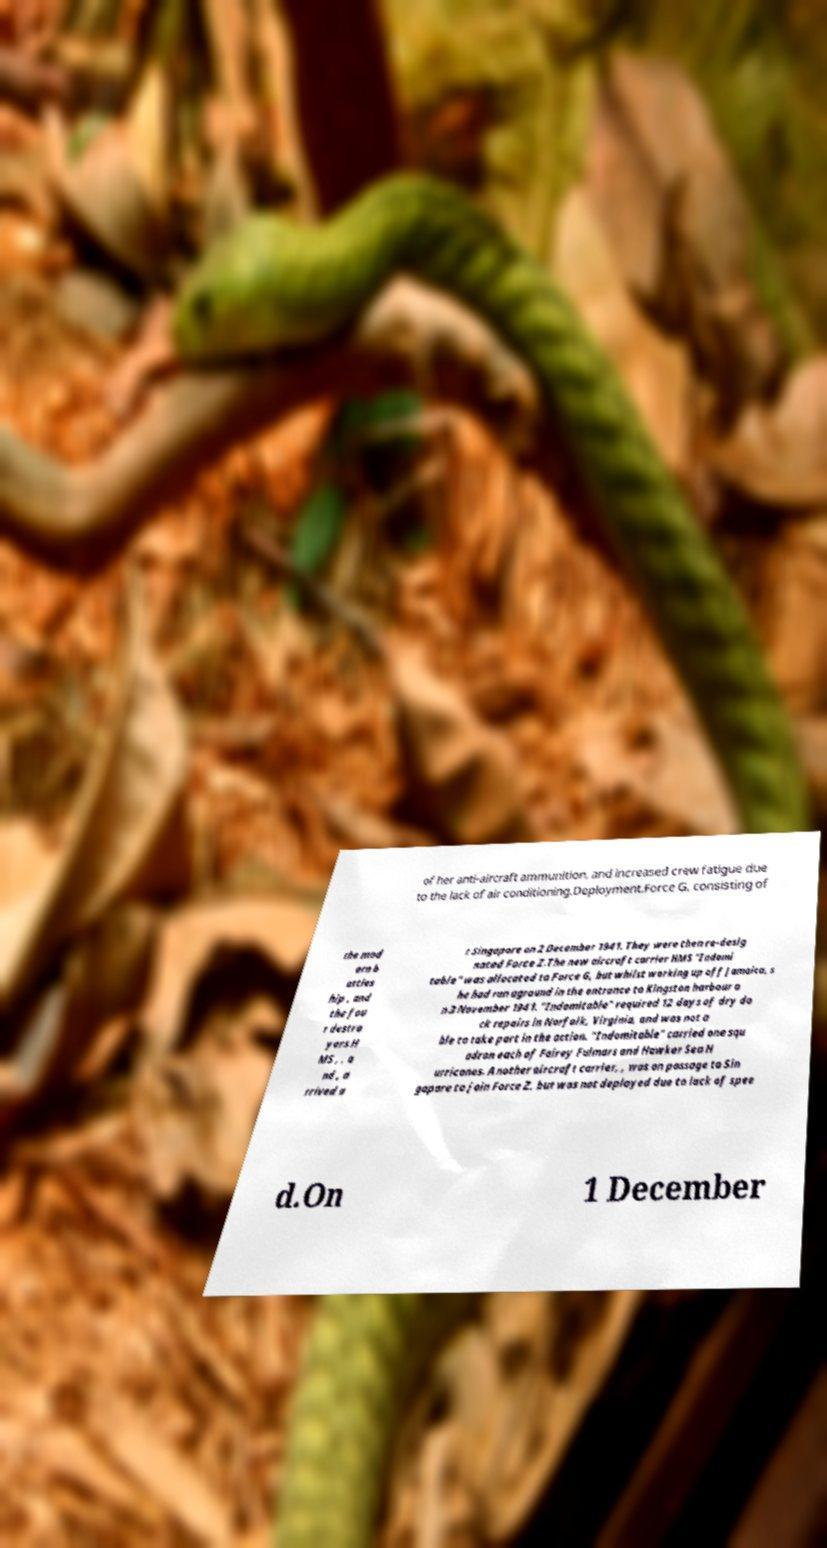There's text embedded in this image that I need extracted. Can you transcribe it verbatim? of her anti-aircraft ammunition, and increased crew fatigue due to the lack of air conditioning.Deployment.Force G, consisting of the mod ern b attles hip , and the fou r destro yers H MS , , a nd , a rrived a t Singapore on 2 December 1941. They were then re-desig nated Force Z.The new aircraft carrier HMS "Indomi table" was allocated to Force G, but whilst working up off Jamaica, s he had run aground in the entrance to Kingston harbour o n 3 November 1941. "Indomitable" required 12 days of dry do ck repairs in Norfolk, Virginia, and was not a ble to take part in the action. "Indomitable" carried one squ adron each of Fairey Fulmars and Hawker Sea H urricanes. Another aircraft carrier, , was on passage to Sin gapore to join Force Z, but was not deployed due to lack of spee d.On 1 December 